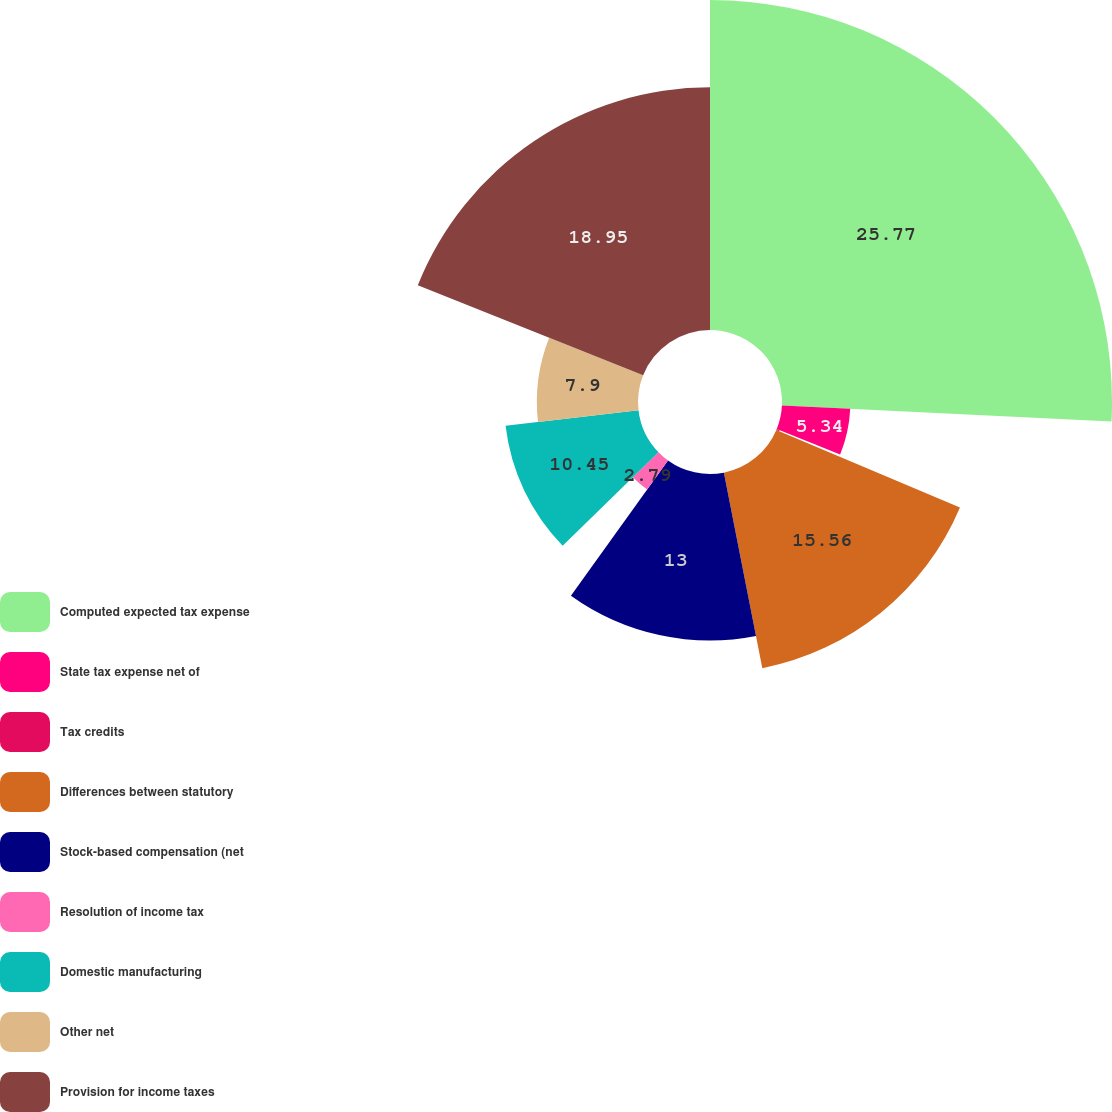Convert chart. <chart><loc_0><loc_0><loc_500><loc_500><pie_chart><fcel>Computed expected tax expense<fcel>State tax expense net of<fcel>Tax credits<fcel>Differences between statutory<fcel>Stock-based compensation (net<fcel>Resolution of income tax<fcel>Domestic manufacturing<fcel>Other net<fcel>Provision for income taxes<nl><fcel>25.77%<fcel>5.34%<fcel>0.24%<fcel>15.56%<fcel>13.0%<fcel>2.79%<fcel>10.45%<fcel>7.9%<fcel>18.95%<nl></chart> 